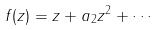<formula> <loc_0><loc_0><loc_500><loc_500>f ( z ) = z + a _ { 2 } z ^ { 2 } + \cdots \,</formula> 